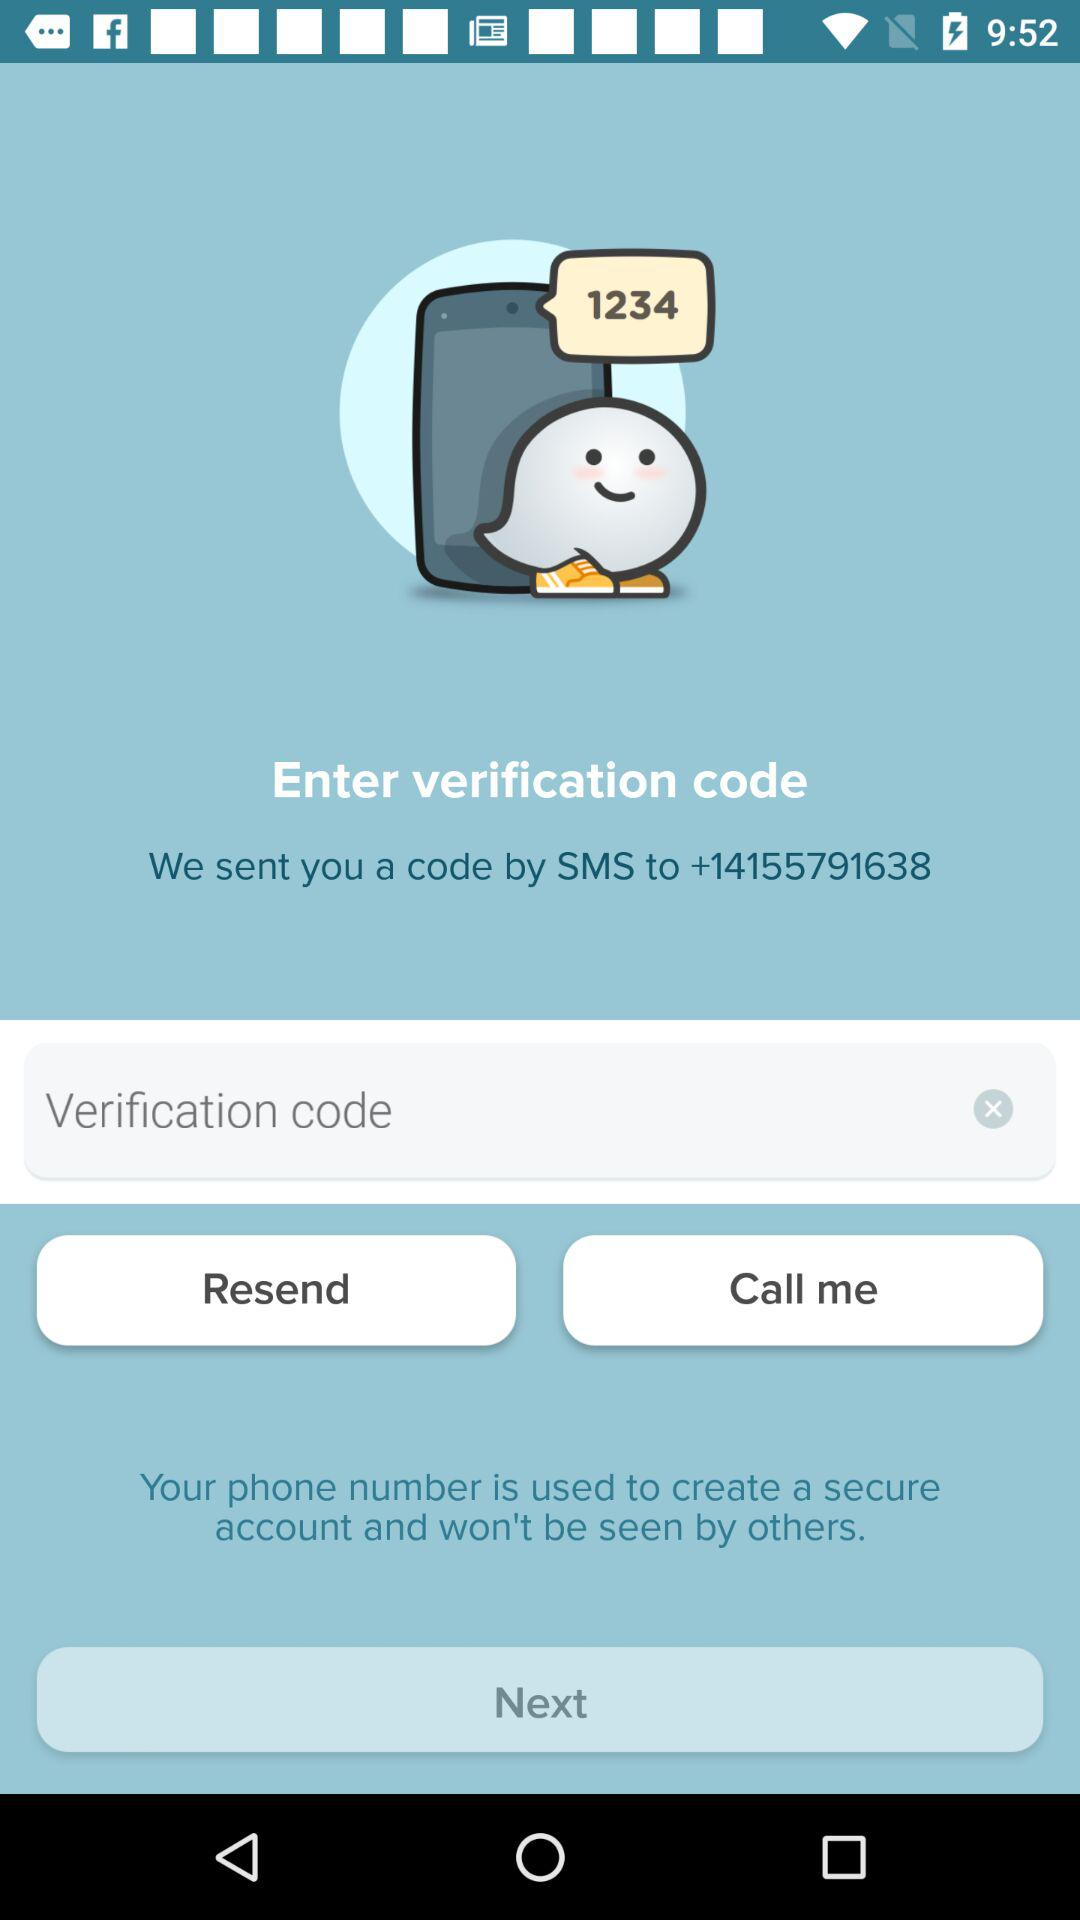What is the number to send the verification code? The number is +14155791638. 